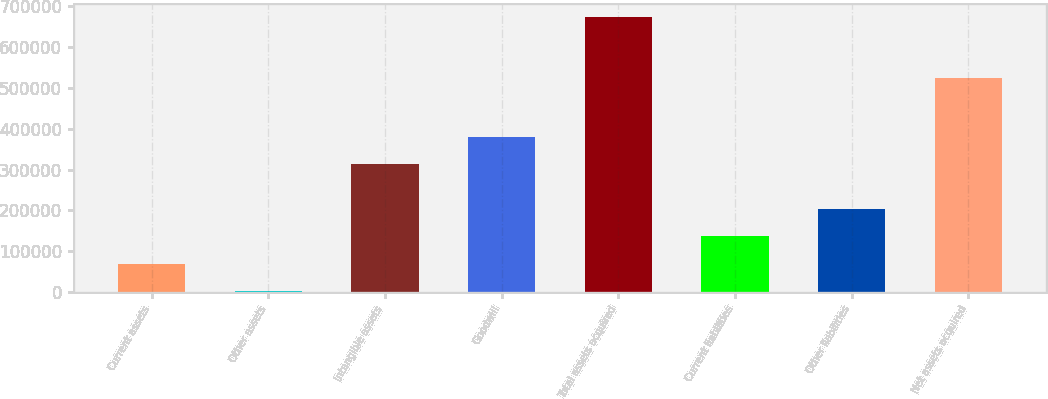<chart> <loc_0><loc_0><loc_500><loc_500><bar_chart><fcel>Current assets<fcel>Other assets<fcel>Intangible assets<fcel>Goodwill<fcel>Total assets acquired<fcel>Current liabilities<fcel>Other liabilities<fcel>Net assets acquired<nl><fcel>69899.7<fcel>2998<fcel>313600<fcel>380502<fcel>672015<fcel>136801<fcel>203703<fcel>522949<nl></chart> 